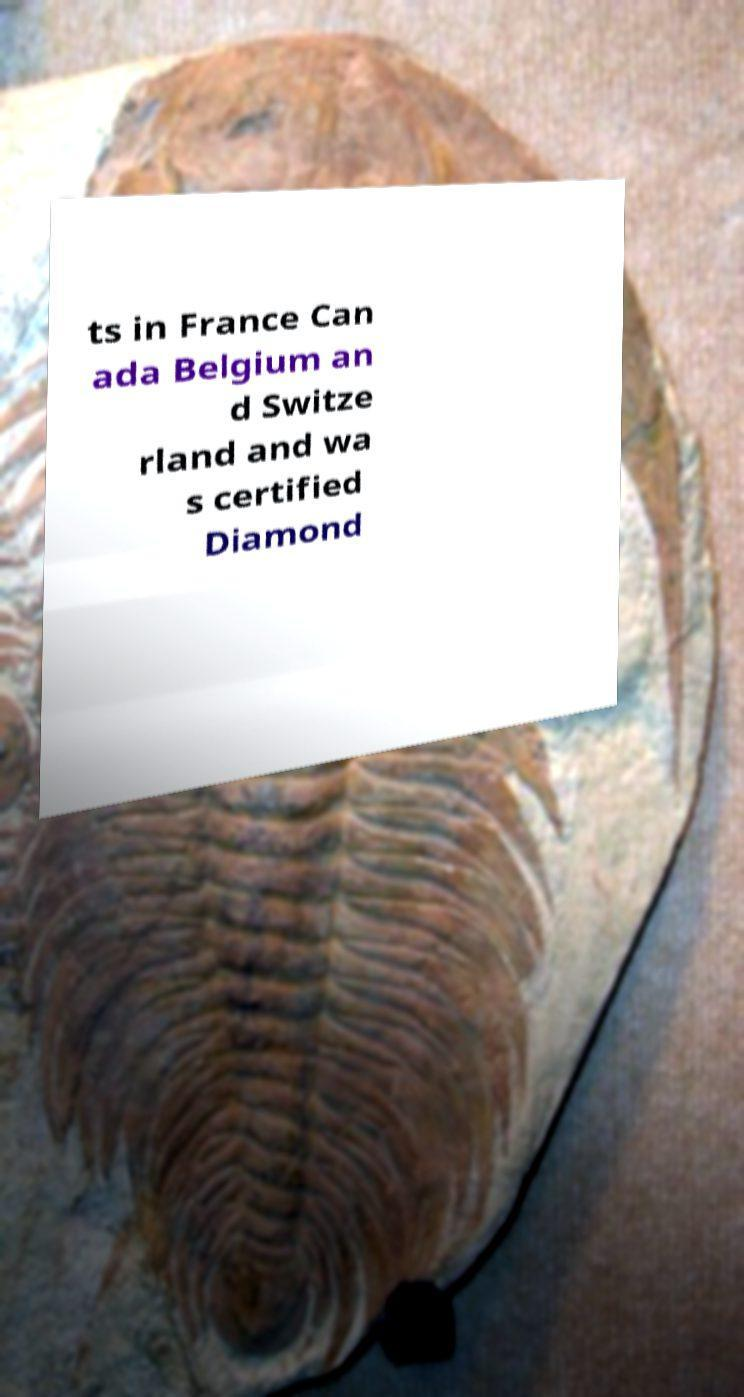What messages or text are displayed in this image? I need them in a readable, typed format. ts in France Can ada Belgium an d Switze rland and wa s certified Diamond 